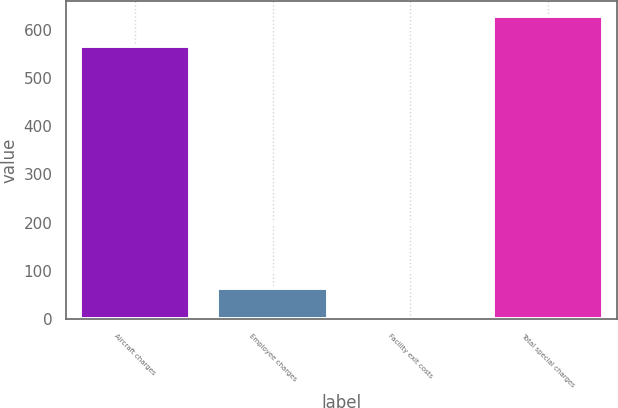Convert chart. <chart><loc_0><loc_0><loc_500><loc_500><bar_chart><fcel>Aircraft charges<fcel>Employee charges<fcel>Facility exit costs<fcel>Total special charges<nl><fcel>565<fcel>65.2<fcel>3<fcel>627.2<nl></chart> 